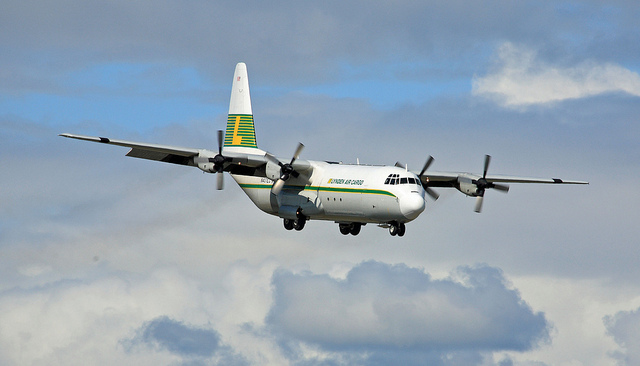Identify the text contained in this image. L 